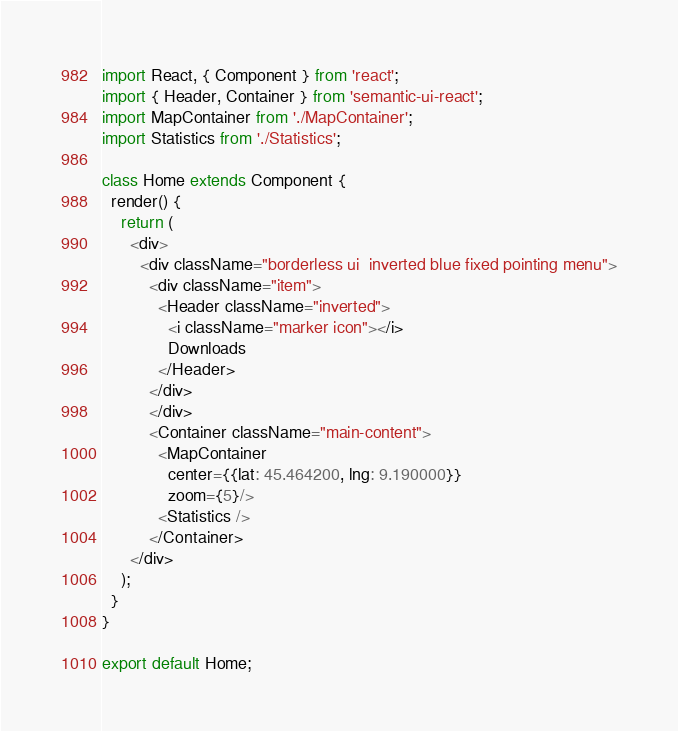<code> <loc_0><loc_0><loc_500><loc_500><_JavaScript_>import React, { Component } from 'react';
import { Header, Container } from 'semantic-ui-react';
import MapContainer from './MapContainer';
import Statistics from './Statistics';

class Home extends Component {
  render() {
    return (
      <div>
        <div className="borderless ui  inverted blue fixed pointing menu">
          <div className="item">
            <Header className="inverted">
              <i className="marker icon"></i>
              Downloads
            </Header>
          </div>
          </div>
          <Container className="main-content">
            <MapContainer
              center={{lat: 45.464200, lng: 9.190000}}
              zoom={5}/>
            <Statistics />
          </Container>
      </div>
    );
  }
}

export default Home;
</code> 